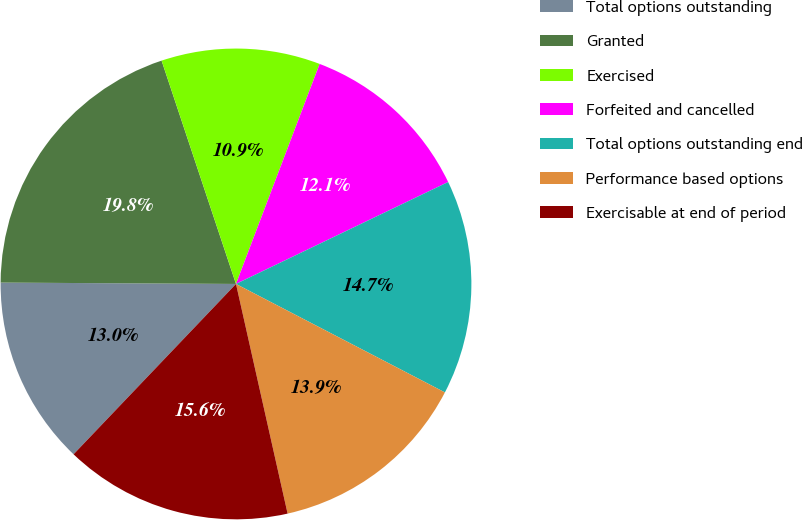<chart> <loc_0><loc_0><loc_500><loc_500><pie_chart><fcel>Total options outstanding<fcel>Granted<fcel>Exercised<fcel>Forfeited and cancelled<fcel>Total options outstanding end<fcel>Performance based options<fcel>Exercisable at end of period<nl><fcel>12.97%<fcel>19.79%<fcel>10.9%<fcel>12.09%<fcel>14.75%<fcel>13.86%<fcel>15.64%<nl></chart> 